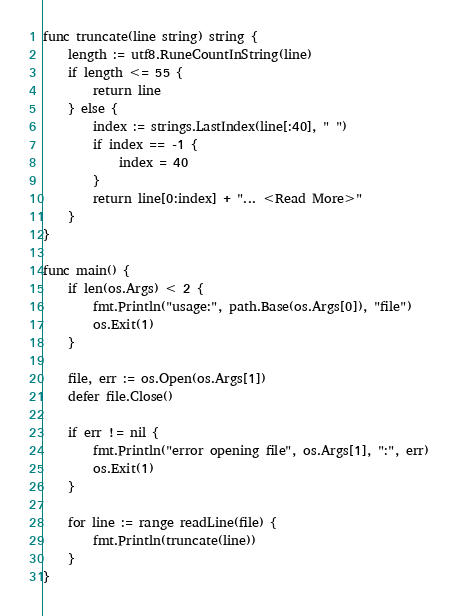Convert code to text. <code><loc_0><loc_0><loc_500><loc_500><_Go_>func truncate(line string) string {
	length := utf8.RuneCountInString(line)
	if length <= 55 {
		return line
	} else {
		index := strings.LastIndex(line[:40], " ")
		if index == -1 {
			index = 40
		}
		return line[0:index] + "... <Read More>"
	}
}

func main() {
	if len(os.Args) < 2 {
		fmt.Println("usage:", path.Base(os.Args[0]), "file")
		os.Exit(1)
	}

	file, err := os.Open(os.Args[1])
	defer file.Close()

	if err != nil {
		fmt.Println("error opening file", os.Args[1], ":", err)
		os.Exit(1)
	}

	for line := range readLine(file) {
		fmt.Println(truncate(line))
	}
}
</code> 